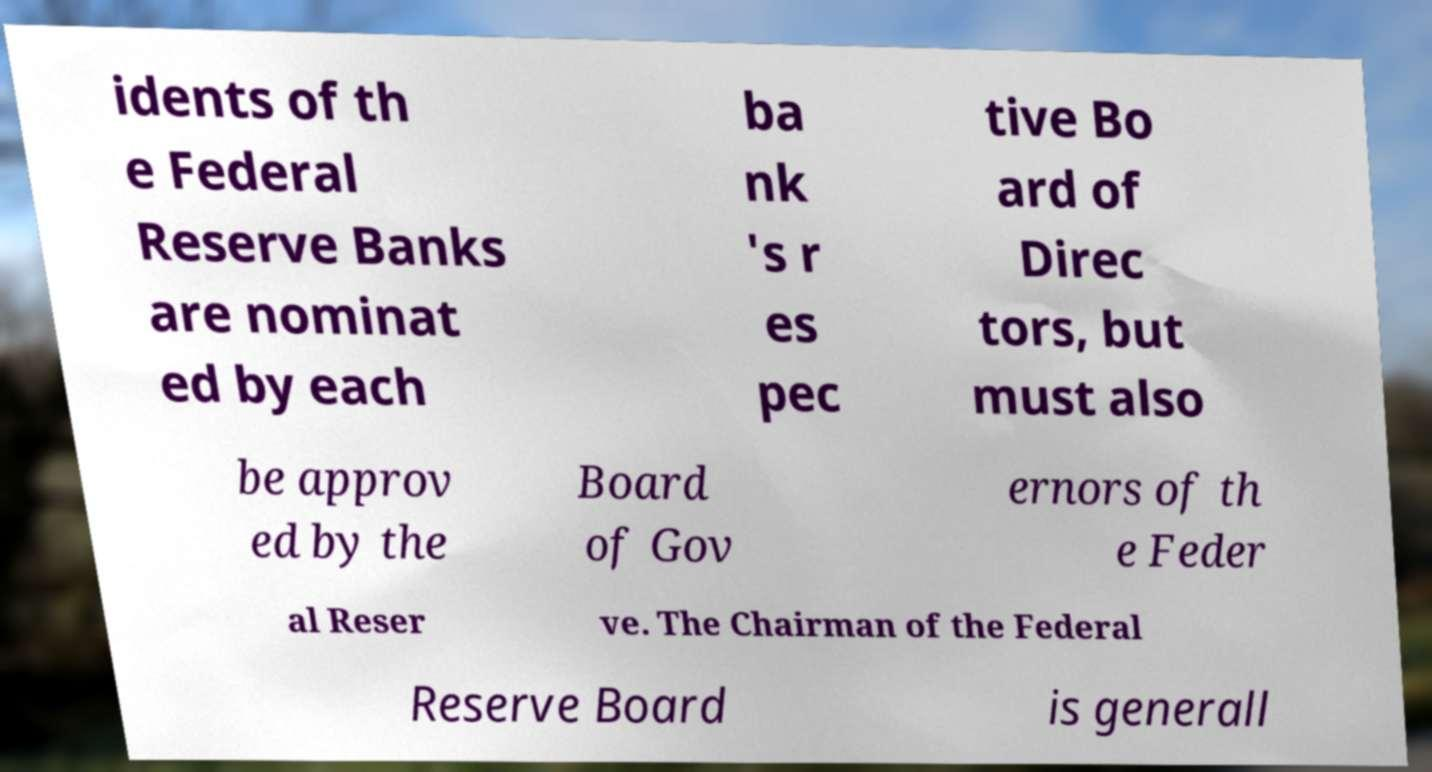Please identify and transcribe the text found in this image. idents of th e Federal Reserve Banks are nominat ed by each ba nk 's r es pec tive Bo ard of Direc tors, but must also be approv ed by the Board of Gov ernors of th e Feder al Reser ve. The Chairman of the Federal Reserve Board is generall 